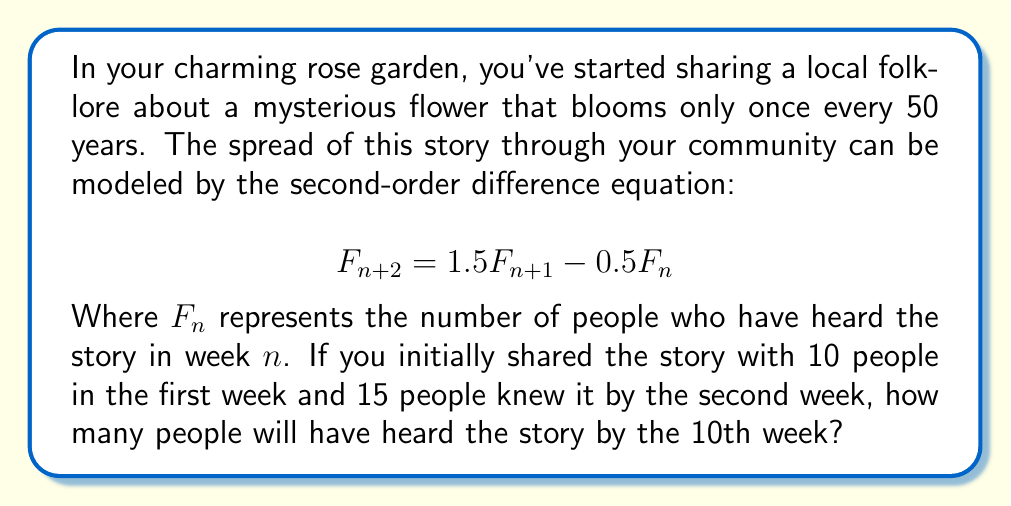Show me your answer to this math problem. To solve this problem, we need to use the given second-order difference equation and the initial conditions. Let's approach this step-by-step:

1) We're given:
   $F_0 = 10$ (initial week)
   $F_1 = 15$ (second week)
   We need to find $F_9$ (10th week, as we start counting from 0)

2) The general form of the equation is:
   $$F_{n+2} = 1.5F_{n+1} - 0.5F_n$$

3) To solve this, we need to find the characteristic equation:
   $$r^2 = 1.5r - 0.5$$
   $$r^2 - 1.5r + 0.5 = 0$$

4) Solving this quadratic equation:
   $$r = \frac{1.5 \pm \sqrt{1.5^2 - 4(1)(0.5)}}{2(1)} = \frac{1.5 \pm \sqrt{1.25}}{2} = \frac{1.5 \pm 1.118}{2}$$
   $$r_1 = 1.309, r_2 = 0.191$$

5) The general solution is:
   $$F_n = c_1(1.309)^n + c_2(0.191)^n$$

6) Using the initial conditions to find $c_1$ and $c_2$:
   $$10 = c_1 + c_2$$
   $$15 = 1.309c_1 + 0.191c_2$$

7) Solving these equations:
   $$c_1 = 11.36, c_2 = -1.36$$

8) Therefore, the particular solution is:
   $$F_n = 11.36(1.309)^n - 1.36(0.191)^n$$

9) For the 10th week (n = 9):
   $$F_9 = 11.36(1.309)^9 - 1.36(0.191)^9 = 245.76 - 0.00046 \approx 245.76$$

10) Rounding to the nearest whole number of people:
    $$F_9 \approx 246$$
Answer: 246 people will have heard the story by the 10th week. 